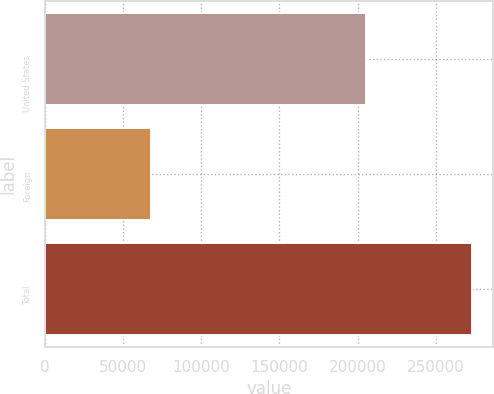Convert chart to OTSL. <chart><loc_0><loc_0><loc_500><loc_500><bar_chart><fcel>United States<fcel>Foreign<fcel>Total<nl><fcel>205148<fcel>68005<fcel>273153<nl></chart> 